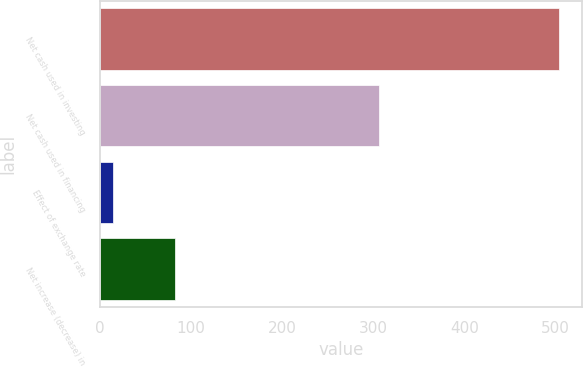Convert chart. <chart><loc_0><loc_0><loc_500><loc_500><bar_chart><fcel>Net cash used in investing<fcel>Net cash used in financing<fcel>Effect of exchange rate<fcel>Net increase (decrease) in<nl><fcel>504.4<fcel>306.4<fcel>13.8<fcel>81.9<nl></chart> 